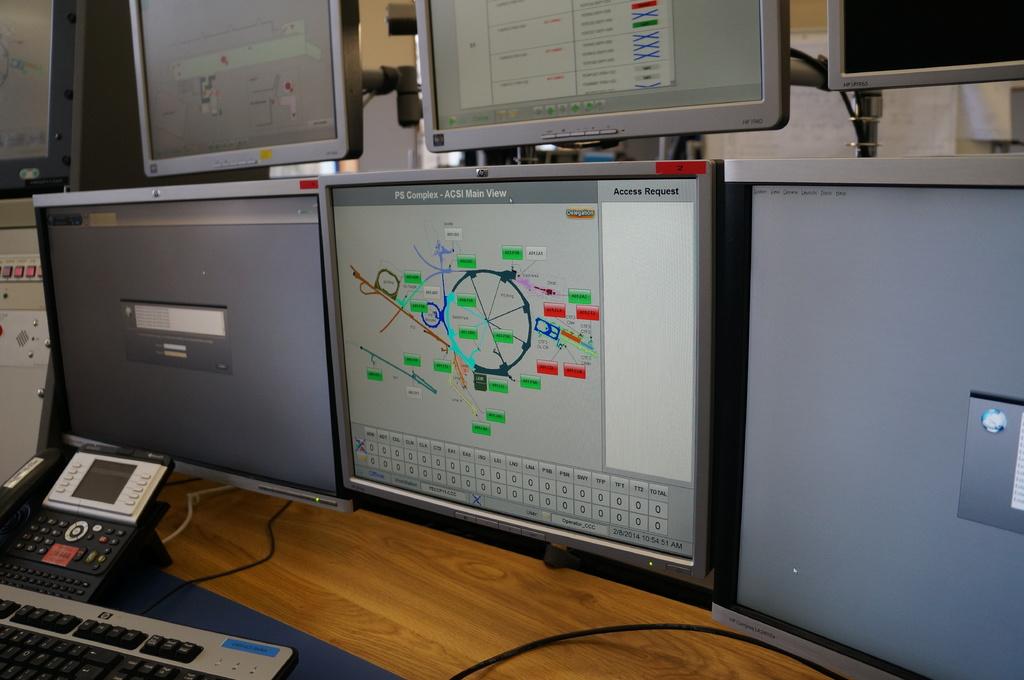Is that the main view?
Ensure brevity in your answer.  Yes. 